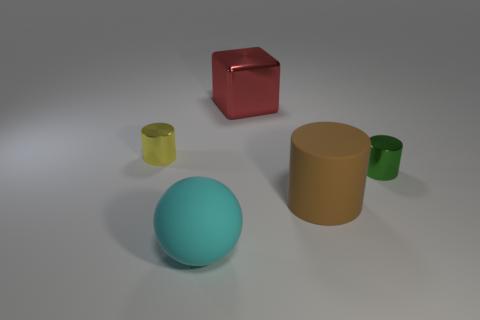The metal object that is the same size as the yellow metallic cylinder is what color?
Offer a very short reply. Green. There is a metal cylinder that is to the left of the large cyan rubber ball; are there any big things that are in front of it?
Make the answer very short. Yes. There is a big thing that is on the left side of the large red cube; what material is it?
Your response must be concise. Rubber. Is the object left of the big cyan matte ball made of the same material as the small cylinder on the right side of the big metallic block?
Make the answer very short. Yes. Is the number of large red blocks that are on the left side of the red cube the same as the number of large brown cylinders that are on the right side of the large brown cylinder?
Ensure brevity in your answer.  Yes. How many other spheres have the same material as the ball?
Give a very brief answer. 0. How big is the cube on the left side of the large rubber thing that is behind the cyan rubber object?
Ensure brevity in your answer.  Large. There is a tiny thing that is behind the green thing; does it have the same shape as the small object on the right side of the rubber sphere?
Make the answer very short. Yes. Is the number of tiny green cylinders on the left side of the large brown cylinder the same as the number of metallic balls?
Provide a short and direct response. Yes. What is the color of the big rubber thing that is the same shape as the green metallic object?
Provide a short and direct response. Brown. 